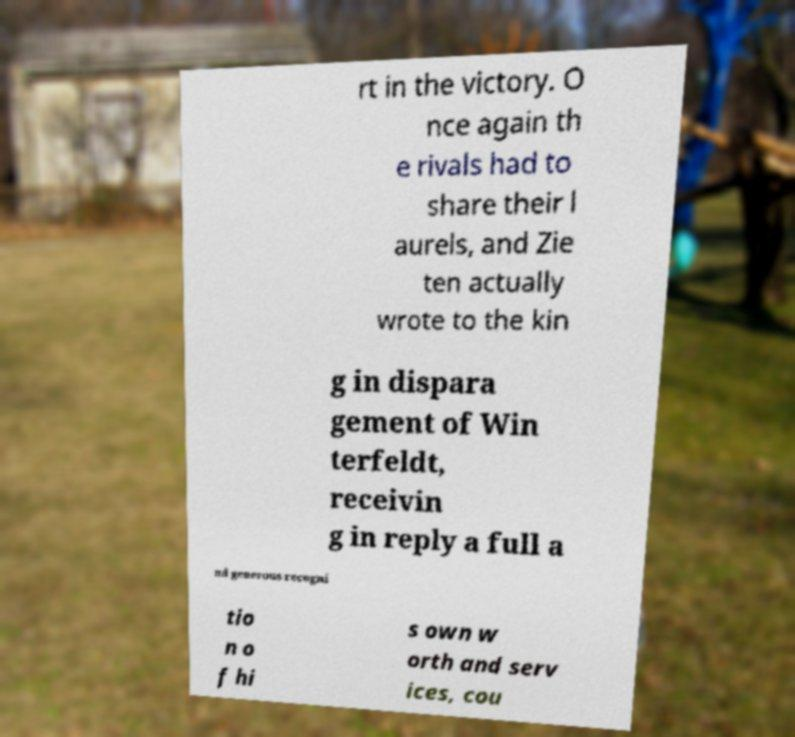Can you read and provide the text displayed in the image?This photo seems to have some interesting text. Can you extract and type it out for me? rt in the victory. O nce again th e rivals had to share their l aurels, and Zie ten actually wrote to the kin g in dispara gement of Win terfeldt, receivin g in reply a full a nd generous recogni tio n o f hi s own w orth and serv ices, cou 